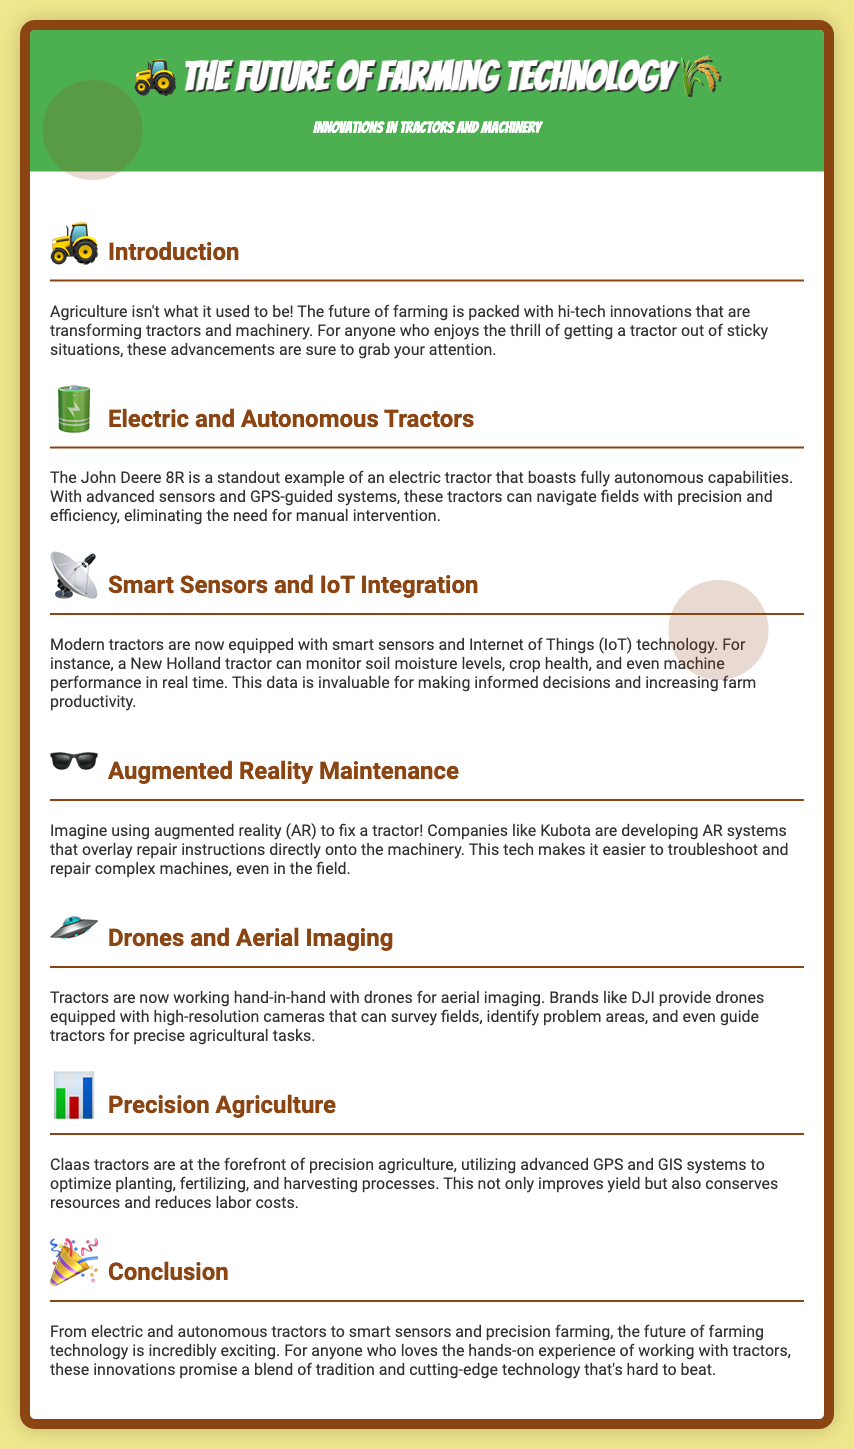what is the title of the playbill? The title is found at the top of the document in large text, showcasing the main theme.
Answer: The Future of Farming Technology who is a standout example of an electric tractor? The document specifically mentions a notable model in the section about electric tractors.
Answer: John Deere 8R what technology allows tractors to monitor soil moisture levels? The section on smart sensors details the technology used in modern tractors for monitoring.
Answer: IoT technology which company is developing augmented reality systems for tractor maintenance? The document provides information about a company focusing on AR technology in tractor repair.
Answer: Kubota what agricultural technique utilizes advanced GPS and GIS systems? The precision agriculture section explains the technology used for optimizing farming processes.
Answer: Precision agriculture how do drones assist tractors in agriculture? The document describes the function of drones in the context of tractor work and farming efficiency.
Answer: Aerial imaging what is one benefit of precision agriculture mentioned in the document? The conclusion of that section states the benefits of using this modern agricultural approach.
Answer: Improves yield 